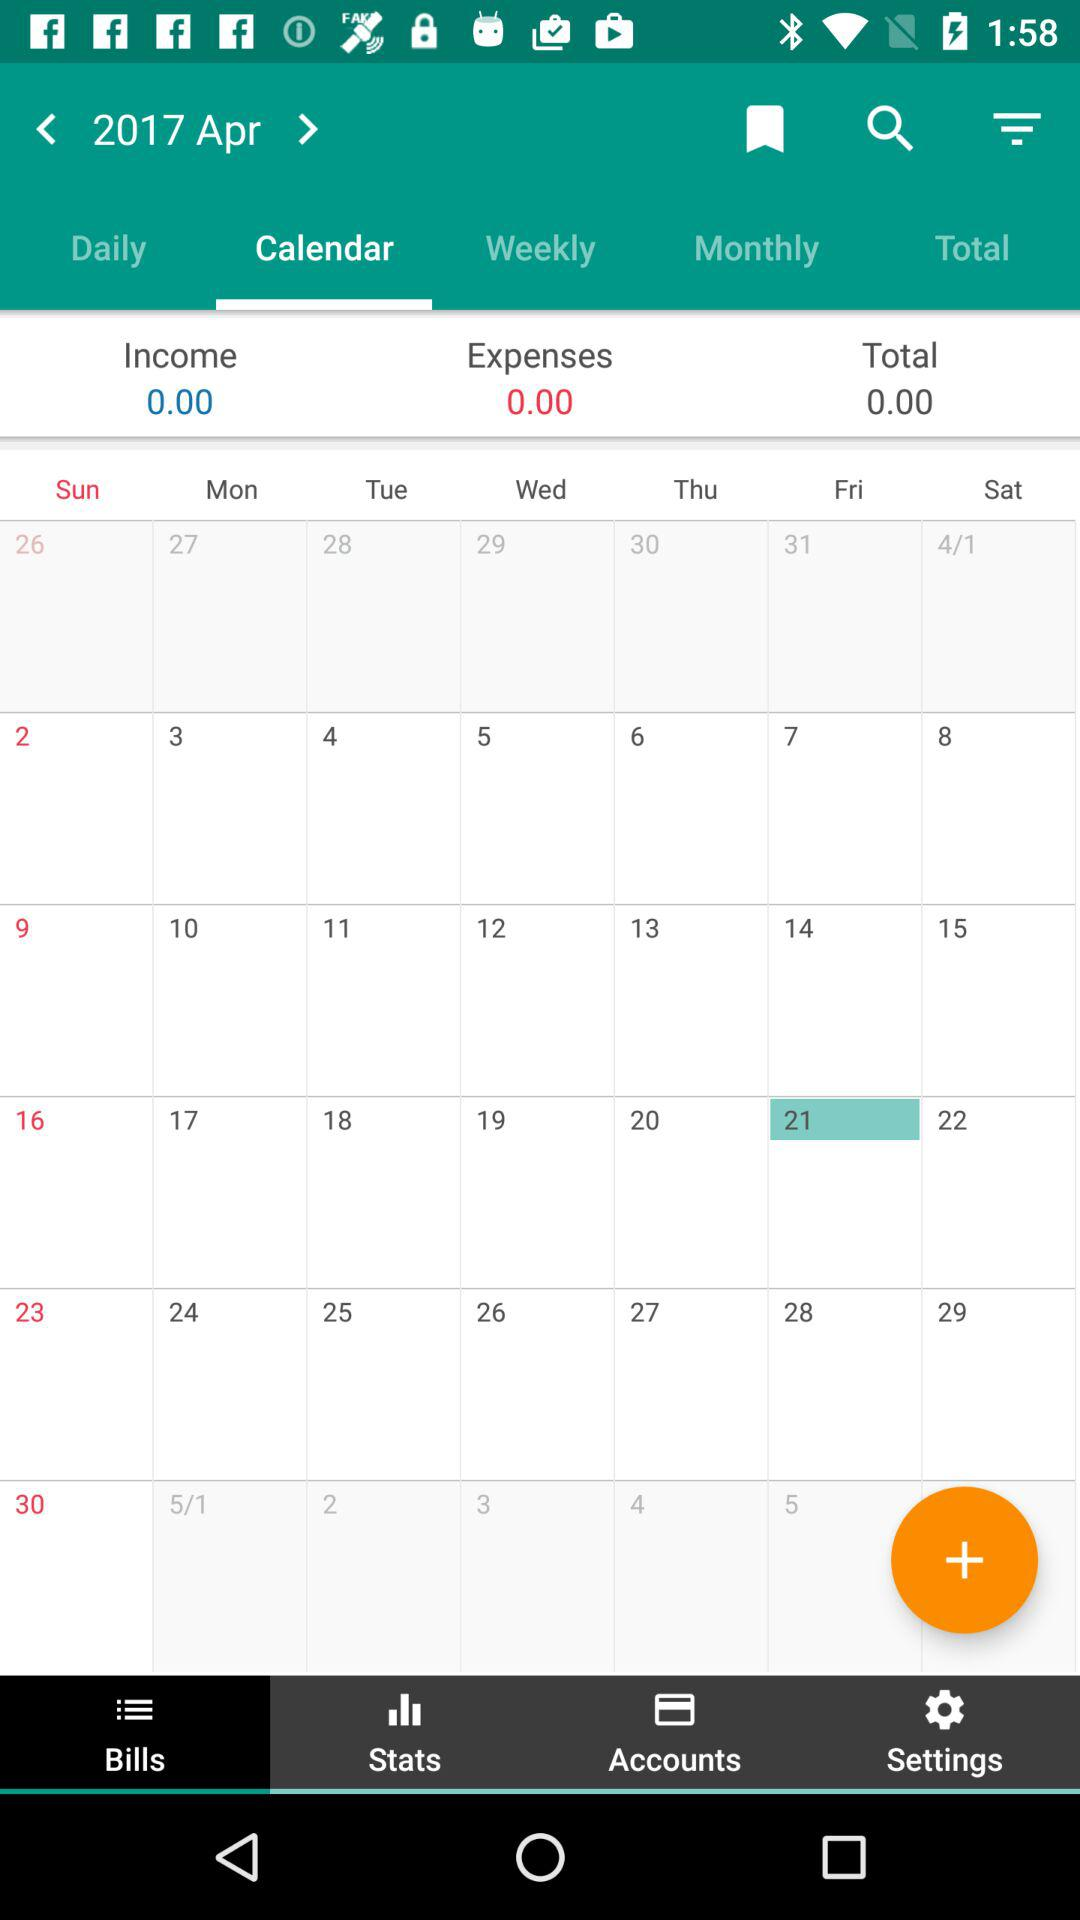Which tab has been selected? The tabs that have been selected are "Calendar" and "Bills". 